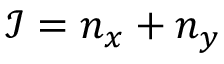<formula> <loc_0><loc_0><loc_500><loc_500>\mathcal { I } = n _ { x } + n _ { y }</formula> 